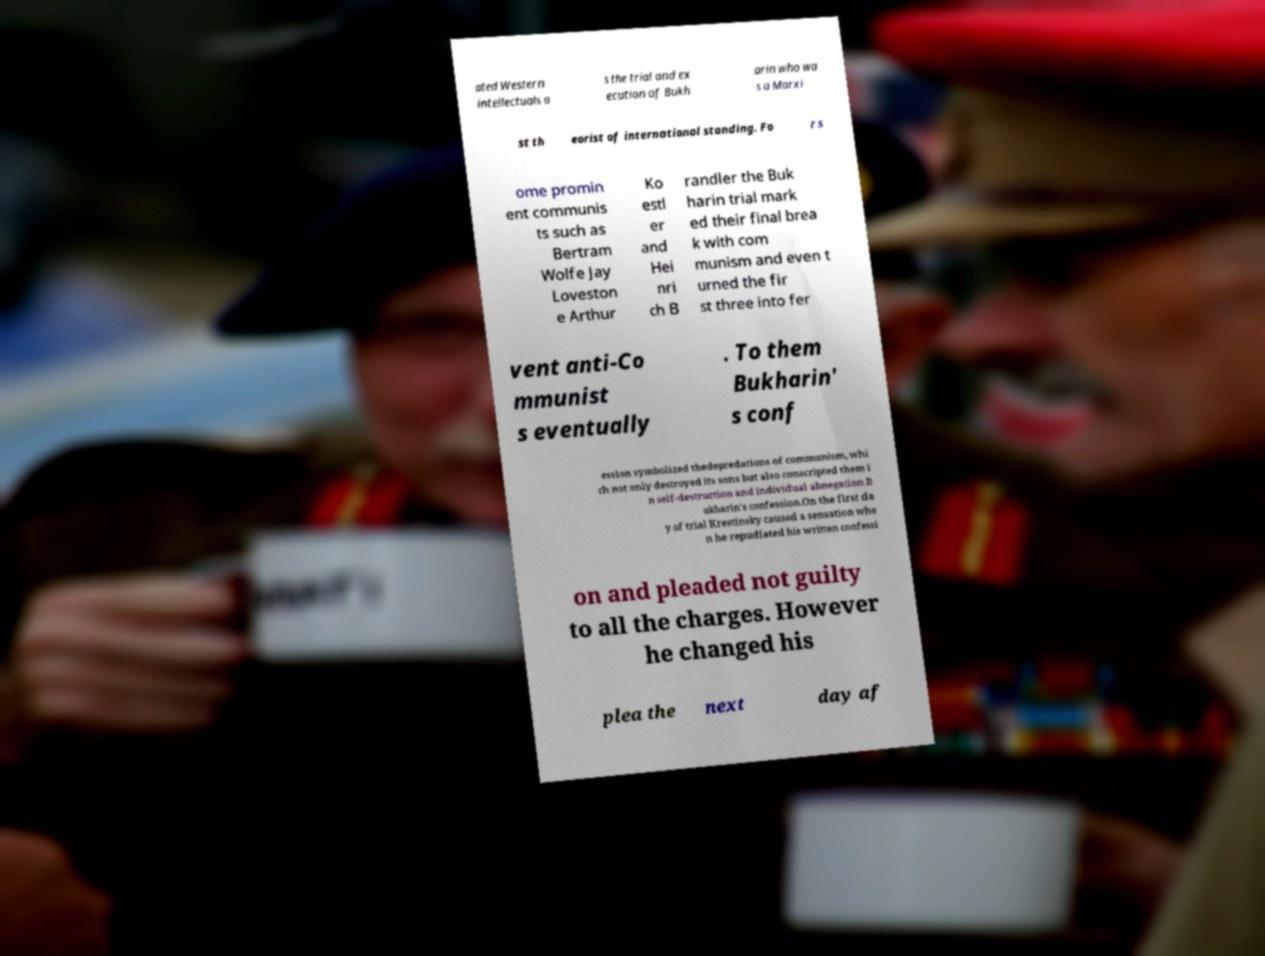What messages or text are displayed in this image? I need them in a readable, typed format. ated Western intellectuals a s the trial and ex ecution of Bukh arin who wa s a Marxi st th eorist of international standing. Fo r s ome promin ent communis ts such as Bertram Wolfe Jay Loveston e Arthur Ko estl er and Hei nri ch B randler the Buk harin trial mark ed their final brea k with com munism and even t urned the fir st three into fer vent anti-Co mmunist s eventually . To them Bukharin' s conf ession symbolized thedepredations of communism, whi ch not only destroyed its sons but also conscripted them i n self-destruction and individual abnegation.B ukharin's confession.On the first da y of trial Krestinsky caused a sensation whe n he repudiated his written confessi on and pleaded not guilty to all the charges. However he changed his plea the next day af 